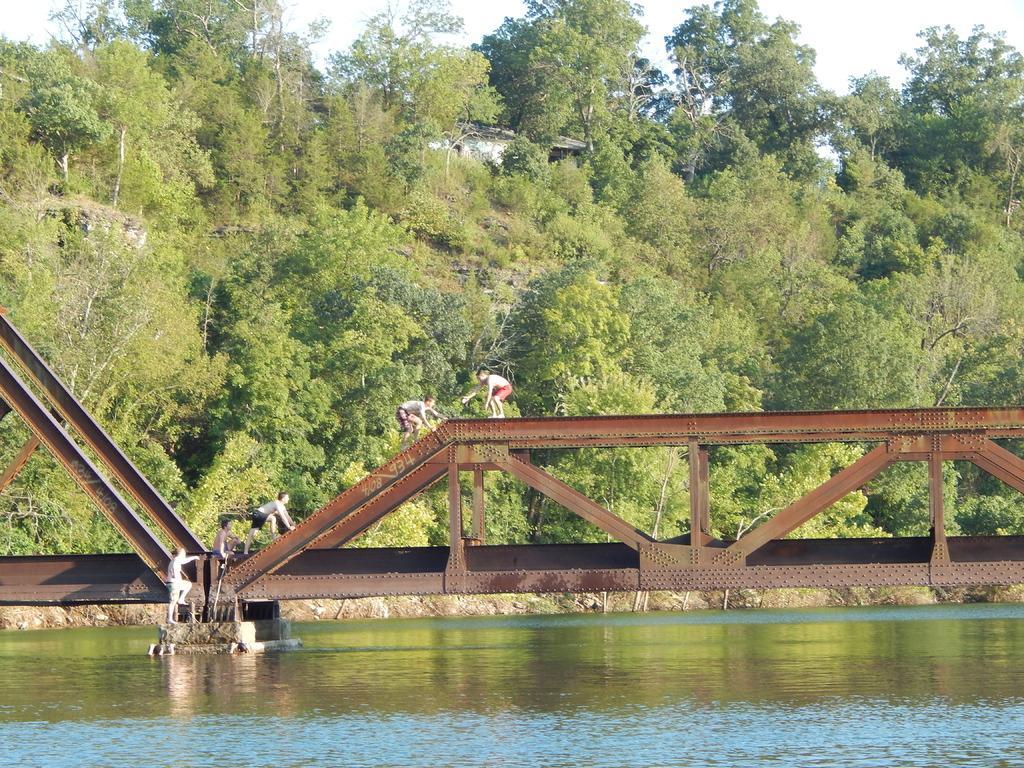Can you describe this image briefly? In this image we can see sky, building, trees, persons standing on the bridge and climbing bridge from the water. 